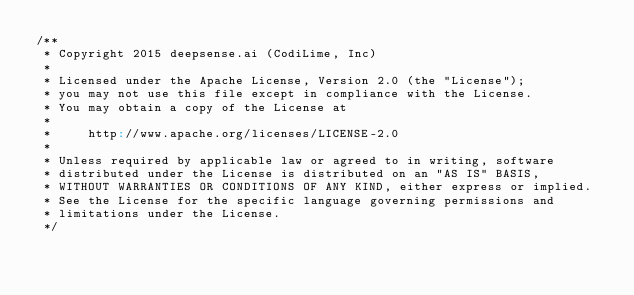Convert code to text. <code><loc_0><loc_0><loc_500><loc_500><_Scala_>/**
 * Copyright 2015 deepsense.ai (CodiLime, Inc)
 *
 * Licensed under the Apache License, Version 2.0 (the "License");
 * you may not use this file except in compliance with the License.
 * You may obtain a copy of the License at
 *
 *     http://www.apache.org/licenses/LICENSE-2.0
 *
 * Unless required by applicable law or agreed to in writing, software
 * distributed under the License is distributed on an "AS IS" BASIS,
 * WITHOUT WARRANTIES OR CONDITIONS OF ANY KIND, either express or implied.
 * See the License for the specific language governing permissions and
 * limitations under the License.
 */
</code> 